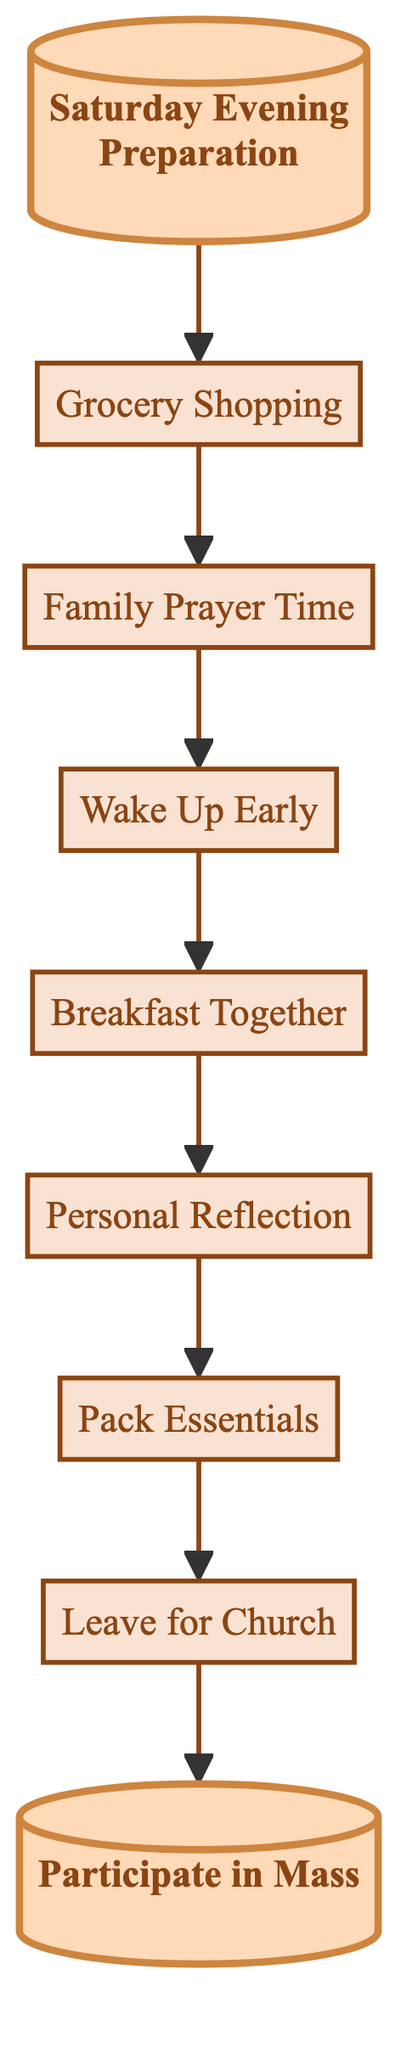What is the first step for preparing for Sunday Mass? The first step in the flow chart is "Saturday Evening Preparation," which is indicated as the starting point of the diagram.
Answer: Saturday Evening Preparation How many steps are there in the process? By counting the individual steps presented in the flow chart, we can see there are a total of nine distinct steps in the preparation process.
Answer: 9 What step comes after "Wake Up Early"? In the flow chart, the step that directly follows "Wake Up Early" is "Breakfast Together," indicating the order of preparation activities.
Answer: Breakfast Together What is the final step in the preparation for Sunday Mass? The last step shown in the flow chart is "Participate in Mass," which concludes the sequence of activities outlined in the diagram.
Answer: Participate in Mass Which step is highlighted in the diagram? The flow chart specifically highlights "Saturday Evening Preparation" at the beginning and "Participate in Mass" at the end, showing their significance.
Answer: Saturday Evening Preparation and Participate in Mass What is required before "Leave for Church"? Before "Leave for Church," the step "Pack Essentials" must be completed, as indicated by the flow in the diagram showing the order of actions.
Answer: Pack Essentials 